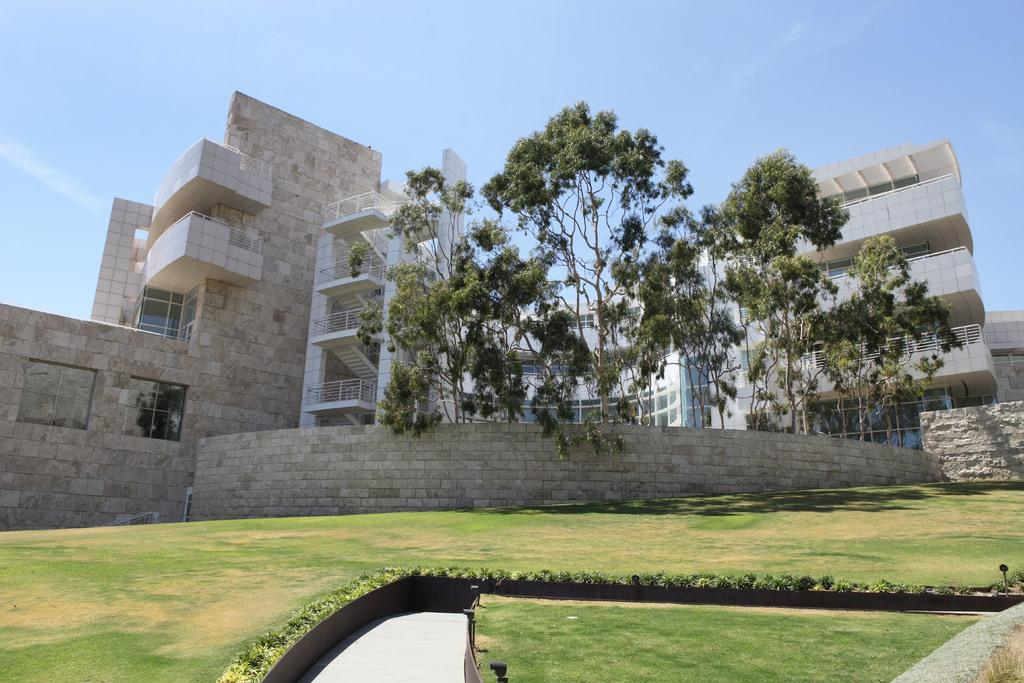What type of terrain is visible in the image? There is land visible in the image. What is the vegetation like on the land? The land is full of grass. Are there any structures on the land? Yes, there are buildings on the land. What other natural elements can be seen in the image? Trees are present in the image. What type of nail is being used to hang the shoe on the tree in the image? There is no nail or shoe hanging on a tree in the image; it only features land, grass, buildings, and trees. 